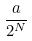Convert formula to latex. <formula><loc_0><loc_0><loc_500><loc_500>\frac { a } { 2 ^ { N } }</formula> 